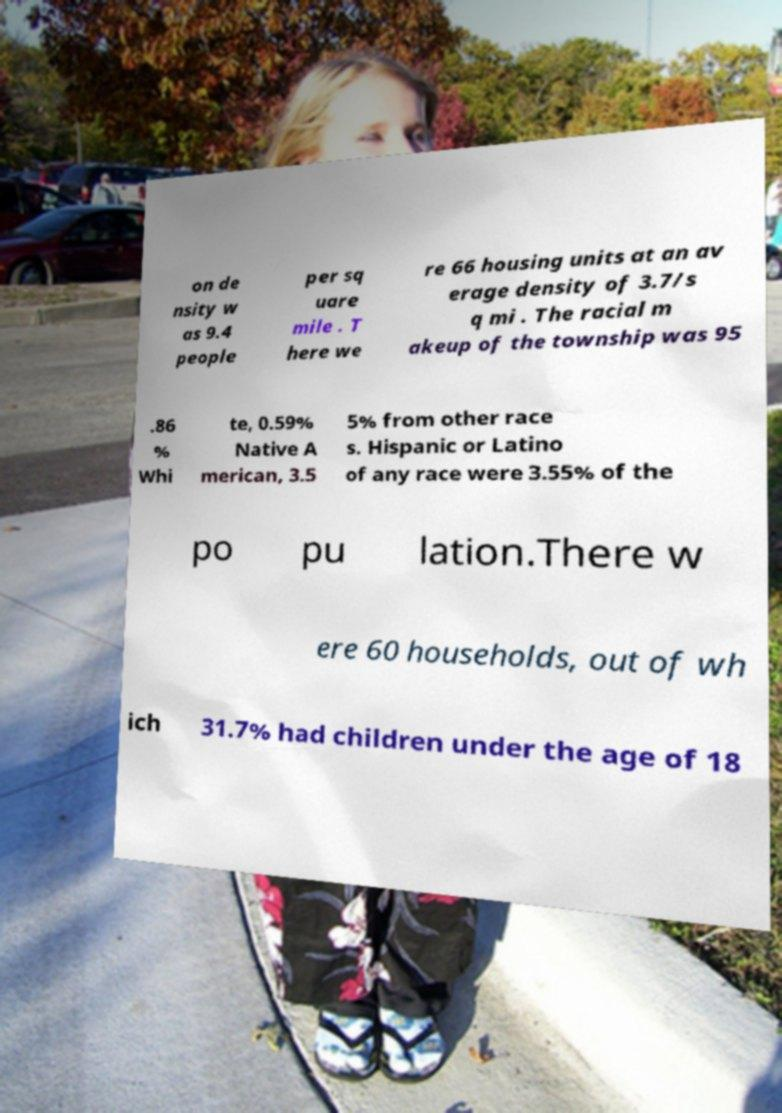What messages or text are displayed in this image? I need them in a readable, typed format. on de nsity w as 9.4 people per sq uare mile . T here we re 66 housing units at an av erage density of 3.7/s q mi . The racial m akeup of the township was 95 .86 % Whi te, 0.59% Native A merican, 3.5 5% from other race s. Hispanic or Latino of any race were 3.55% of the po pu lation.There w ere 60 households, out of wh ich 31.7% had children under the age of 18 